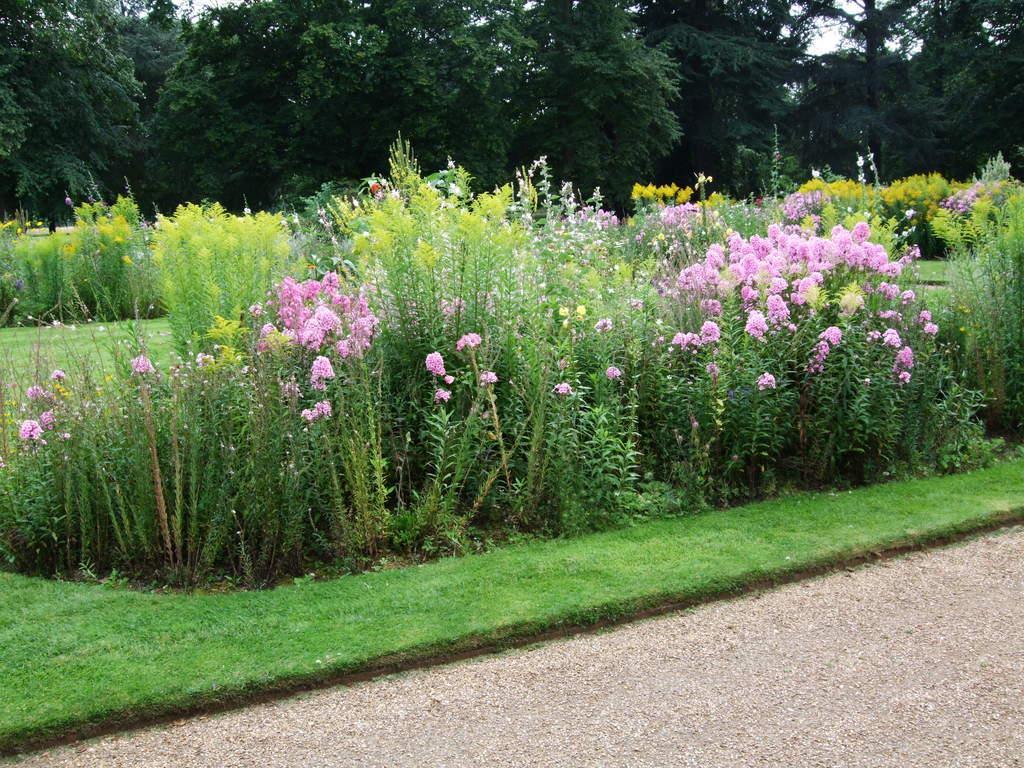Please provide a concise description of this image. In this image there is a land, in the background there is grassland, flower plants and trees. 